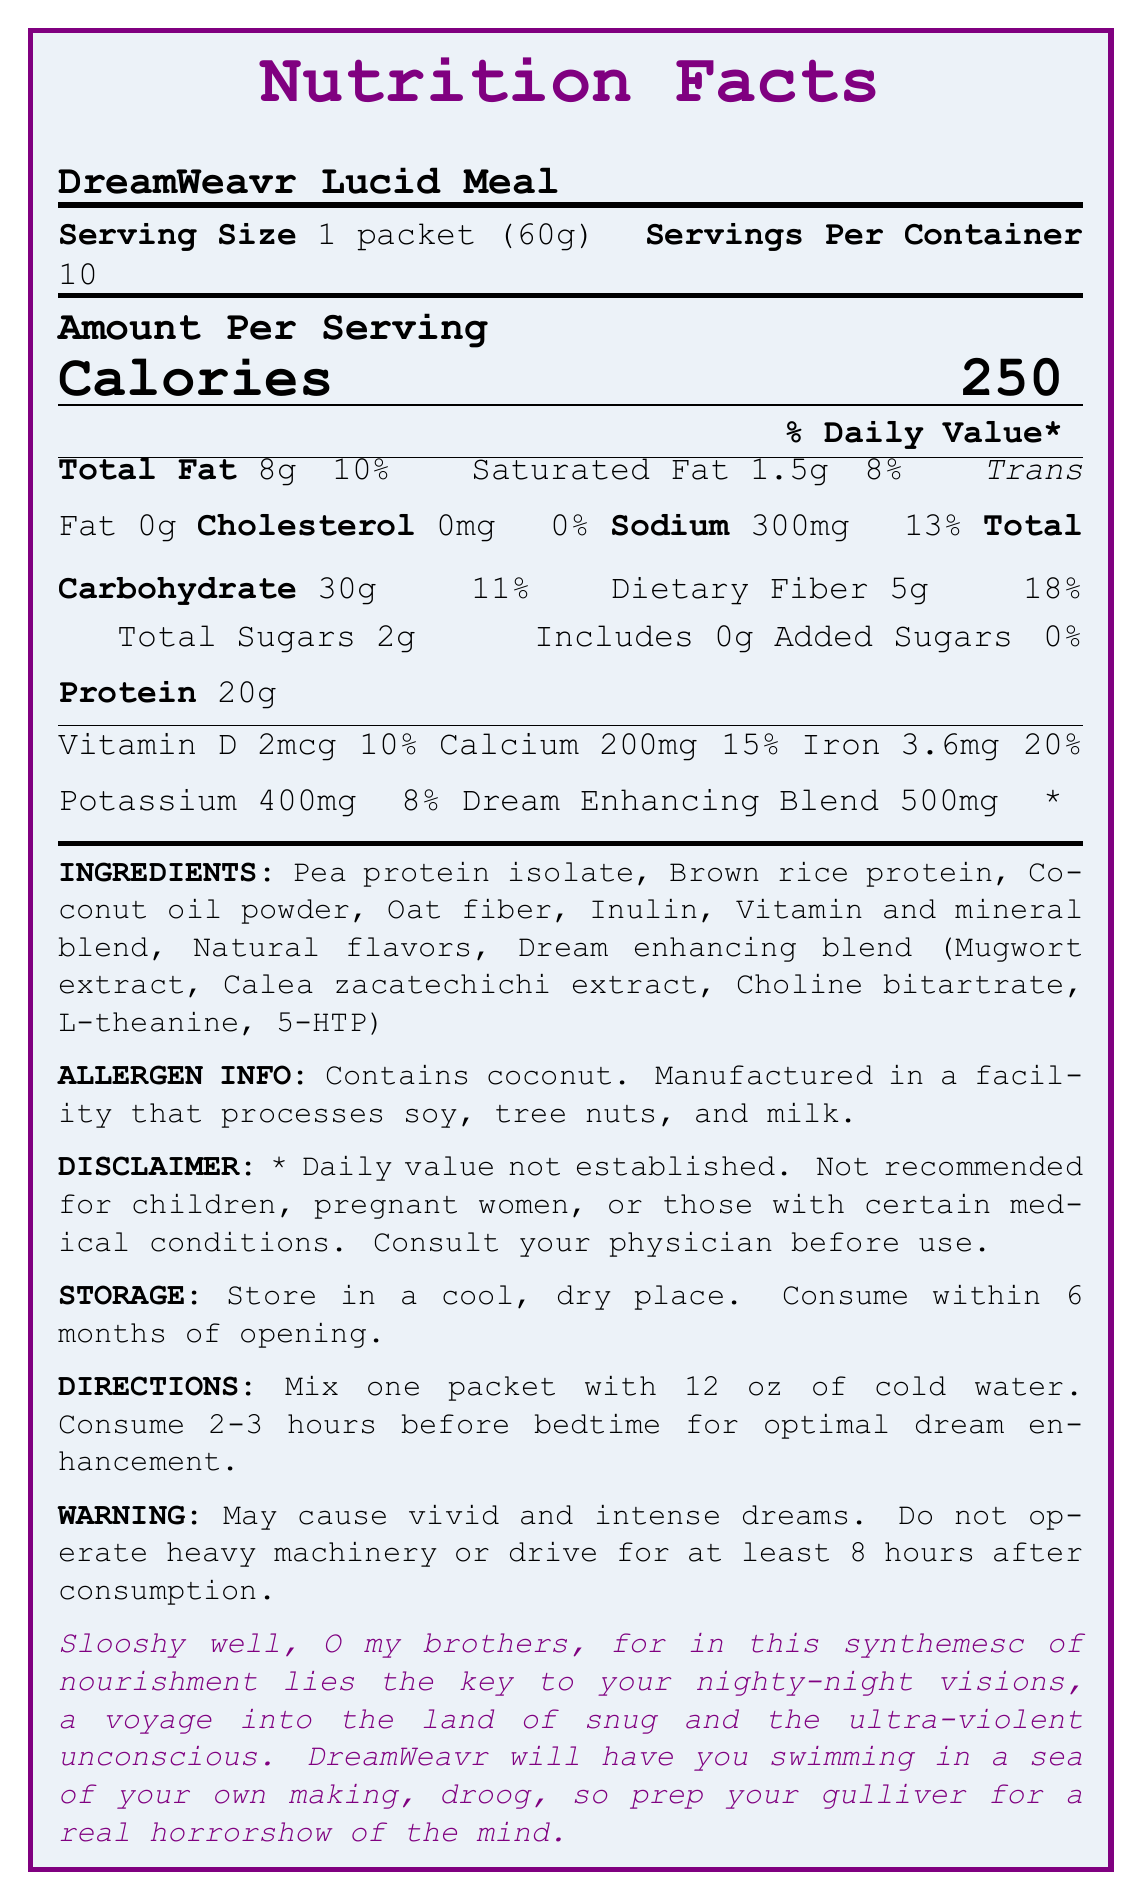what is the serving size of DreamWeavr Lucid Meal? The document specifies that the serving size is 1 packet, which is 60 grams.
Answer: 1 packet (60g) how many servings are in one container of DreamWeavr Lucid Meal? The document states that there are 10 servings per container.
Answer: 10 how many calories are in one serving of DreamWeavr Lucid Meal? The document lists the calories for one serving as 250.
Answer: 250 what is the amount of protein per serving? The protein content per serving is given as 20 grams.
Answer: 20g how much sodium is in each serving? The sodium content per serving is recorded as 300 milligrams.
Answer: 300mg what is the daily value percentage of saturated fat in one serving? Saturated fat's daily value percentage for one serving is 8%.
Answer: 8% which ingredient is listed first in the ingredients list? The first ingredient in the list is Pea protein isolate.
Answer: Pea protein isolate where is the product manufactured that may affect certain allergies? The document mentions that the product is manufactured in a facility that processes soy, tree nuts, and milk.
Answer: A facility that processes soy, tree nuts, and milk what is the daily value percentage of iron in each serving? The iron daily value percentage per serving is 20%.
Answer: 20% how much fiber is in one serving? The document shows that each serving contains 5 grams of dietary fiber.
Answer: 5g how many grams of total sugars are in one serving? A. 0g B. 2g C. 5g D. 8g The Nutrition Facts state that each serving has 2 grams of total sugars.
Answer: B. 2g which of the following is NOT part of the Dream Enhancing Blend? A. Mugwort extract B. L-theanine C. Pea protein isolate D. 5-HTP Pea protein isolate is part of the main ingredients and not the Dream Enhancing Blend.
Answer: C. Pea protein isolate is this product safe for children and pregnant women? The disclaimer clearly states that it is not recommended for children or pregnant women.
Answer: No how should the product be stored? The storage instructions indicate to store the product in a cool, dry place and consume it within 6 months of opening.
Answer: Store in a cool, dry place. Consume within 6 months of opening. what is the main idea of the document? The document provides comprehensive information about the DreamWeavr Lucid Meal, including its nutritional content, ingredients, storage, and usage details, along with specific warnings and caveats.
Answer: DreamWeavr Lucid Meal is a synthetic meal replacement designed to enhance lucid dreaming, with detailed nutritional information, ingredient lists, usage instructions, and warnings. does the product contain any added sugars? The document confirms that there are 0 grams of added sugars in the product.
Answer: No how much calcium does each serving provide, and what percentage of the daily value does this represent? Each serving provides 200 milligrams of calcium, which is 15% of the daily value.
Answer: 200mg, 15% what is the disclaimer regarding daily value percentages for the Dream Enhancing Blend? The disclaimer states that the daily value for the Dream Enhancing Blend has not been established.
Answer: Daily value not established what is the intended effect of consuming DreamWeavr Lucid Meal? The product is designed to enhance lucid dreaming, as indicated in the directions and warning sections.
Answer: Inducing lucid and vivid dreams what are the detailed steps for preparing DreamWeavr Lucid Meal? The directions specify to mix the packet with 12 ounces of cold water and consume it 2-3 hours before bedtime.
Answer: Mix one packet with 12 oz of cold water, and consume 2-3 hours before bedtime for optimal dream enhancement. what is the meaning of "synthemesc" in the context of the document? The document uses the term "synthemesc" in a Burgessian blurb, but it doesn't provide a clear definition.
Answer: Not enough information 